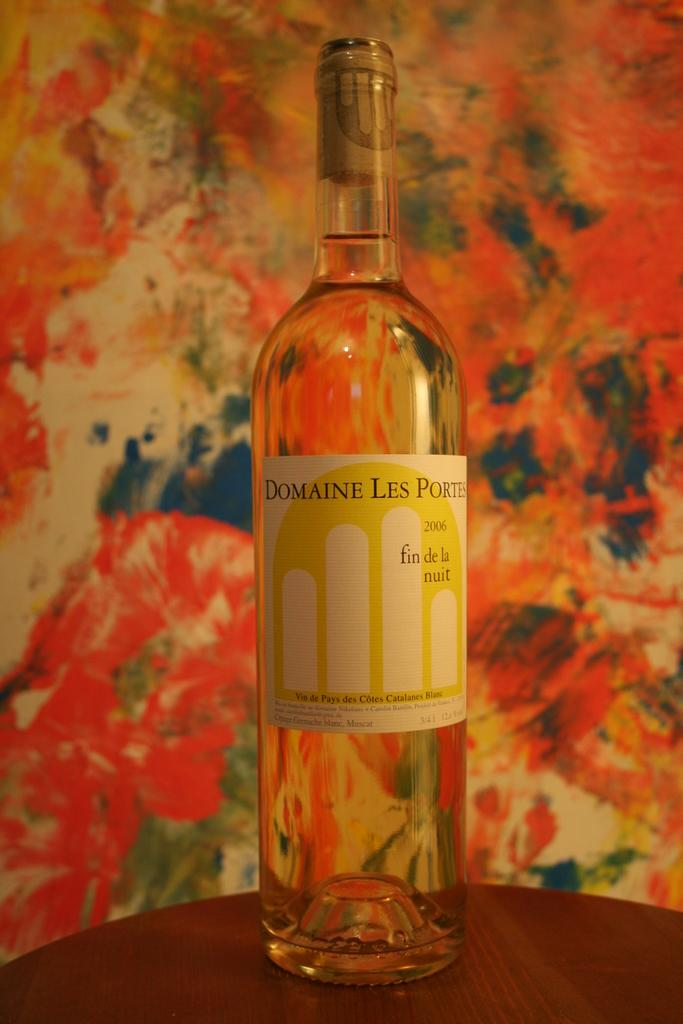<image>
Share a concise interpretation of the image provided. An unopened bottle of Domain Les Portes from 2006 is sitting on the table. 